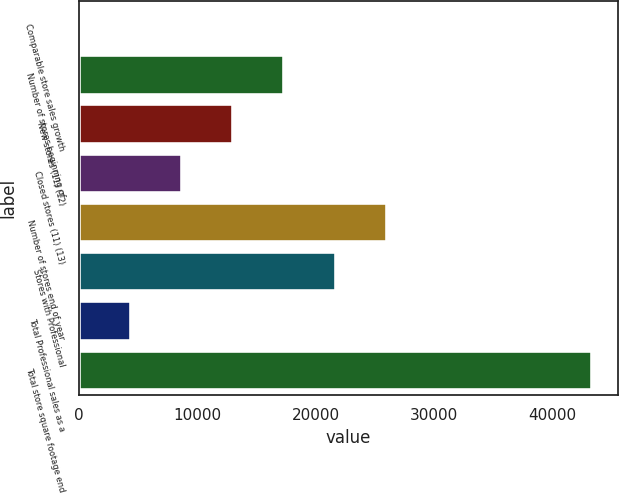<chart> <loc_0><loc_0><loc_500><loc_500><bar_chart><fcel>Comparable store sales growth<fcel>Number of stores beginning of<fcel>New stores (11) (12)<fcel>Closed stores (11) (13)<fcel>Number of stores end of year<fcel>Stores with Professional<fcel>Total Professional sales as a<fcel>Total store square footage end<nl><fcel>2<fcel>17336.4<fcel>13002.8<fcel>8669.2<fcel>26003.6<fcel>21670<fcel>4335.6<fcel>43338<nl></chart> 